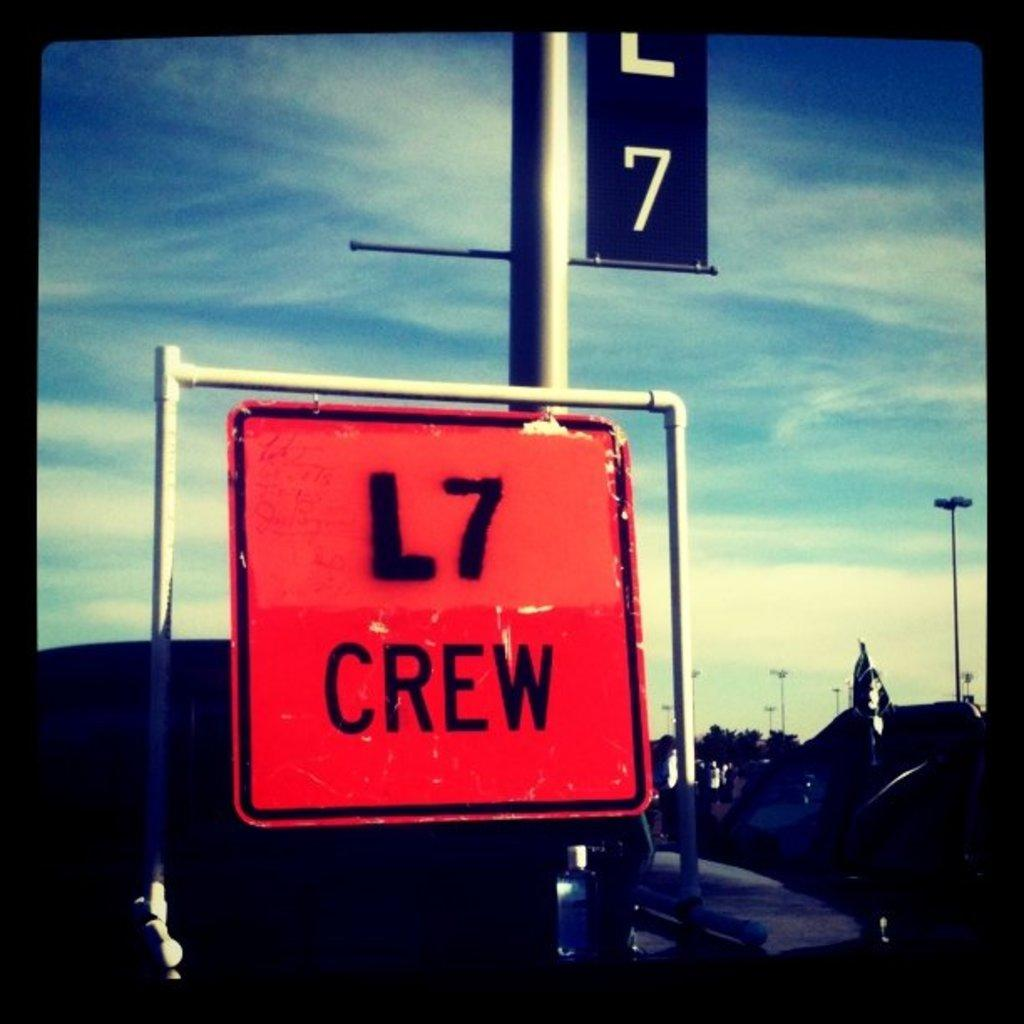<image>
Give a short and clear explanation of the subsequent image. A bright orange sign for the L7 Crew sits under a blue sky. 